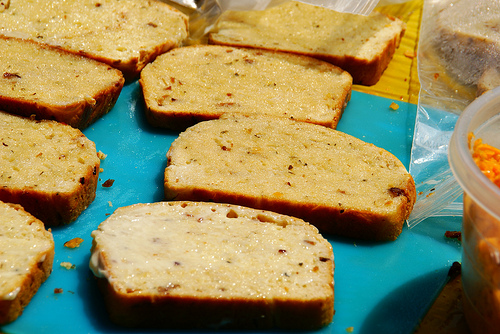<image>
Can you confirm if the bread slice is on the bread slice? Yes. Looking at the image, I can see the bread slice is positioned on top of the bread slice, with the bread slice providing support. 